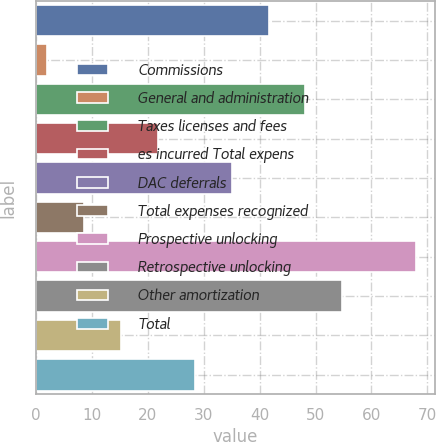Convert chart to OTSL. <chart><loc_0><loc_0><loc_500><loc_500><bar_chart><fcel>Commissions<fcel>General and administration<fcel>Taxes licenses and fees<fcel>es incurred Total expens<fcel>DAC deferrals<fcel>Total expenses recognized<fcel>Prospective unlocking<fcel>Retrospective unlocking<fcel>Other amortization<fcel>Total<nl><fcel>41.6<fcel>2<fcel>48.2<fcel>21.8<fcel>35<fcel>8.6<fcel>68<fcel>54.8<fcel>15.2<fcel>28.4<nl></chart> 